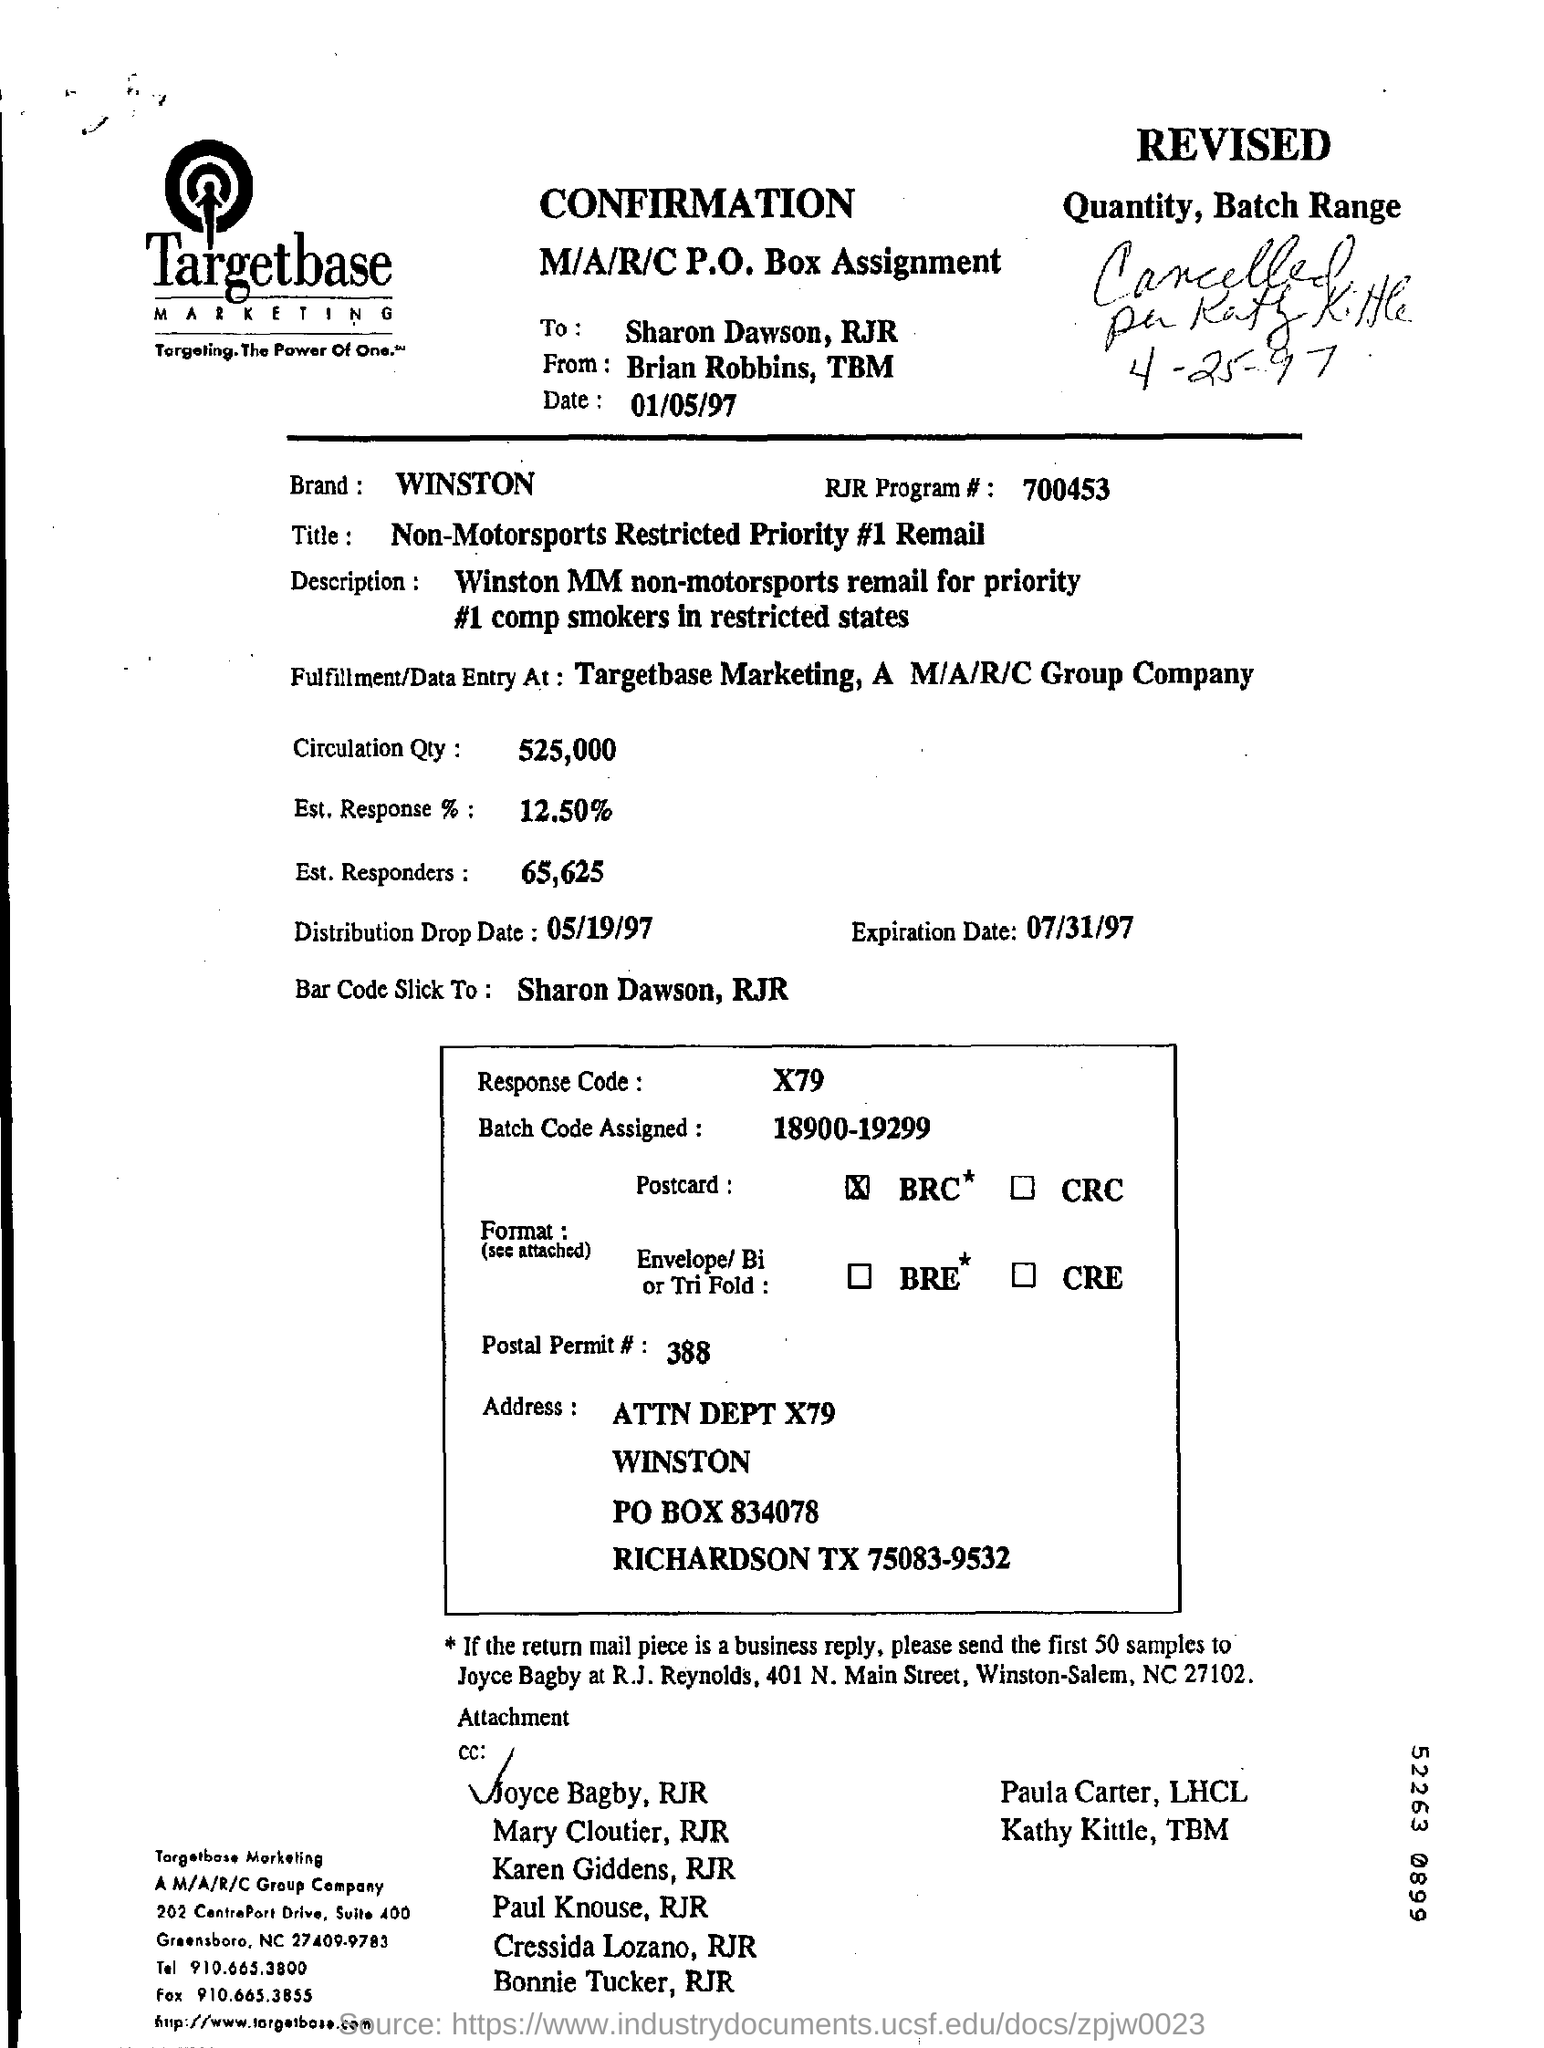Who is this  from?
Offer a terse response. Brian robbins, tbm. Which company's confirmation sheet is this?
Keep it short and to the point. Targetbase. What is the response code given?
Offer a terse response. X79. 